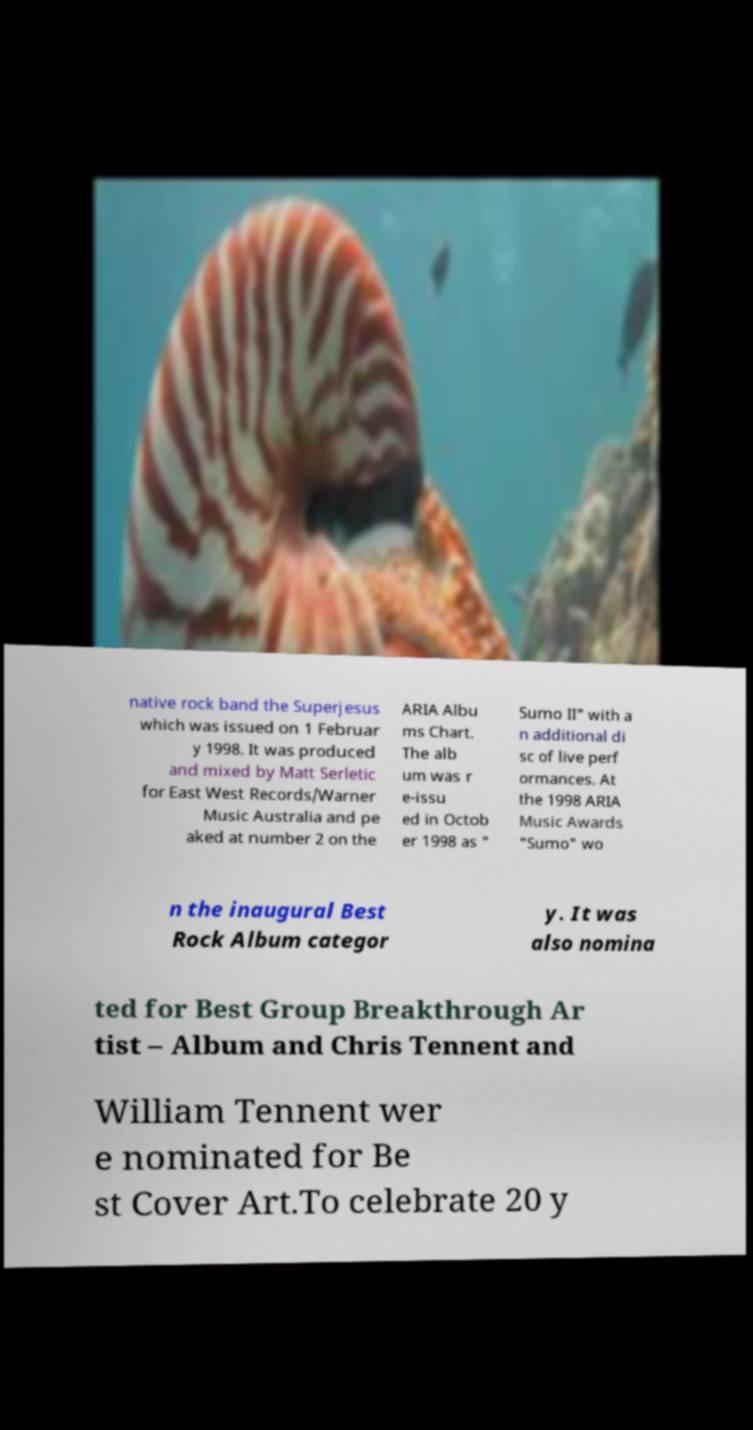Could you extract and type out the text from this image? native rock band the Superjesus which was issued on 1 Februar y 1998. It was produced and mixed by Matt Serletic for East West Records/Warner Music Australia and pe aked at number 2 on the ARIA Albu ms Chart. The alb um was r e-issu ed in Octob er 1998 as " Sumo II" with a n additional di sc of live perf ormances. At the 1998 ARIA Music Awards "Sumo" wo n the inaugural Best Rock Album categor y. It was also nomina ted for Best Group Breakthrough Ar tist – Album and Chris Tennent and William Tennent wer e nominated for Be st Cover Art.To celebrate 20 y 